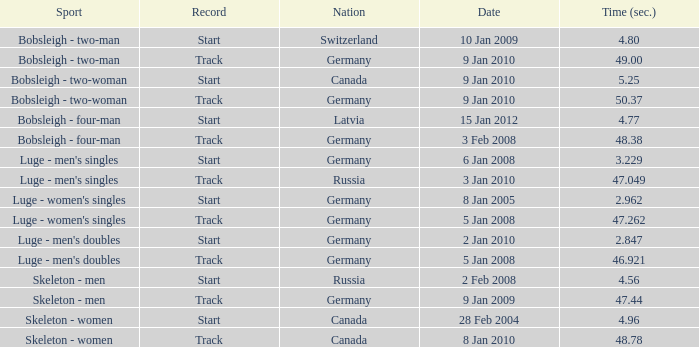For which nation was the completion time recorded as 47.049? Russia. Give me the full table as a dictionary. {'header': ['Sport', 'Record', 'Nation', 'Date', 'Time (sec.)'], 'rows': [['Bobsleigh - two-man', 'Start', 'Switzerland', '10 Jan 2009', '4.80'], ['Bobsleigh - two-man', 'Track', 'Germany', '9 Jan 2010', '49.00'], ['Bobsleigh - two-woman', 'Start', 'Canada', '9 Jan 2010', '5.25'], ['Bobsleigh - two-woman', 'Track', 'Germany', '9 Jan 2010', '50.37'], ['Bobsleigh - four-man', 'Start', 'Latvia', '15 Jan 2012', '4.77'], ['Bobsleigh - four-man', 'Track', 'Germany', '3 Feb 2008', '48.38'], ["Luge - men's singles", 'Start', 'Germany', '6 Jan 2008', '3.229'], ["Luge - men's singles", 'Track', 'Russia', '3 Jan 2010', '47.049'], ["Luge - women's singles", 'Start', 'Germany', '8 Jan 2005', '2.962'], ["Luge - women's singles", 'Track', 'Germany', '5 Jan 2008', '47.262'], ["Luge - men's doubles", 'Start', 'Germany', '2 Jan 2010', '2.847'], ["Luge - men's doubles", 'Track', 'Germany', '5 Jan 2008', '46.921'], ['Skeleton - men', 'Start', 'Russia', '2 Feb 2008', '4.56'], ['Skeleton - men', 'Track', 'Germany', '9 Jan 2009', '47.44'], ['Skeleton - women', 'Start', 'Canada', '28 Feb 2004', '4.96'], ['Skeleton - women', 'Track', 'Canada', '8 Jan 2010', '48.78']]} 